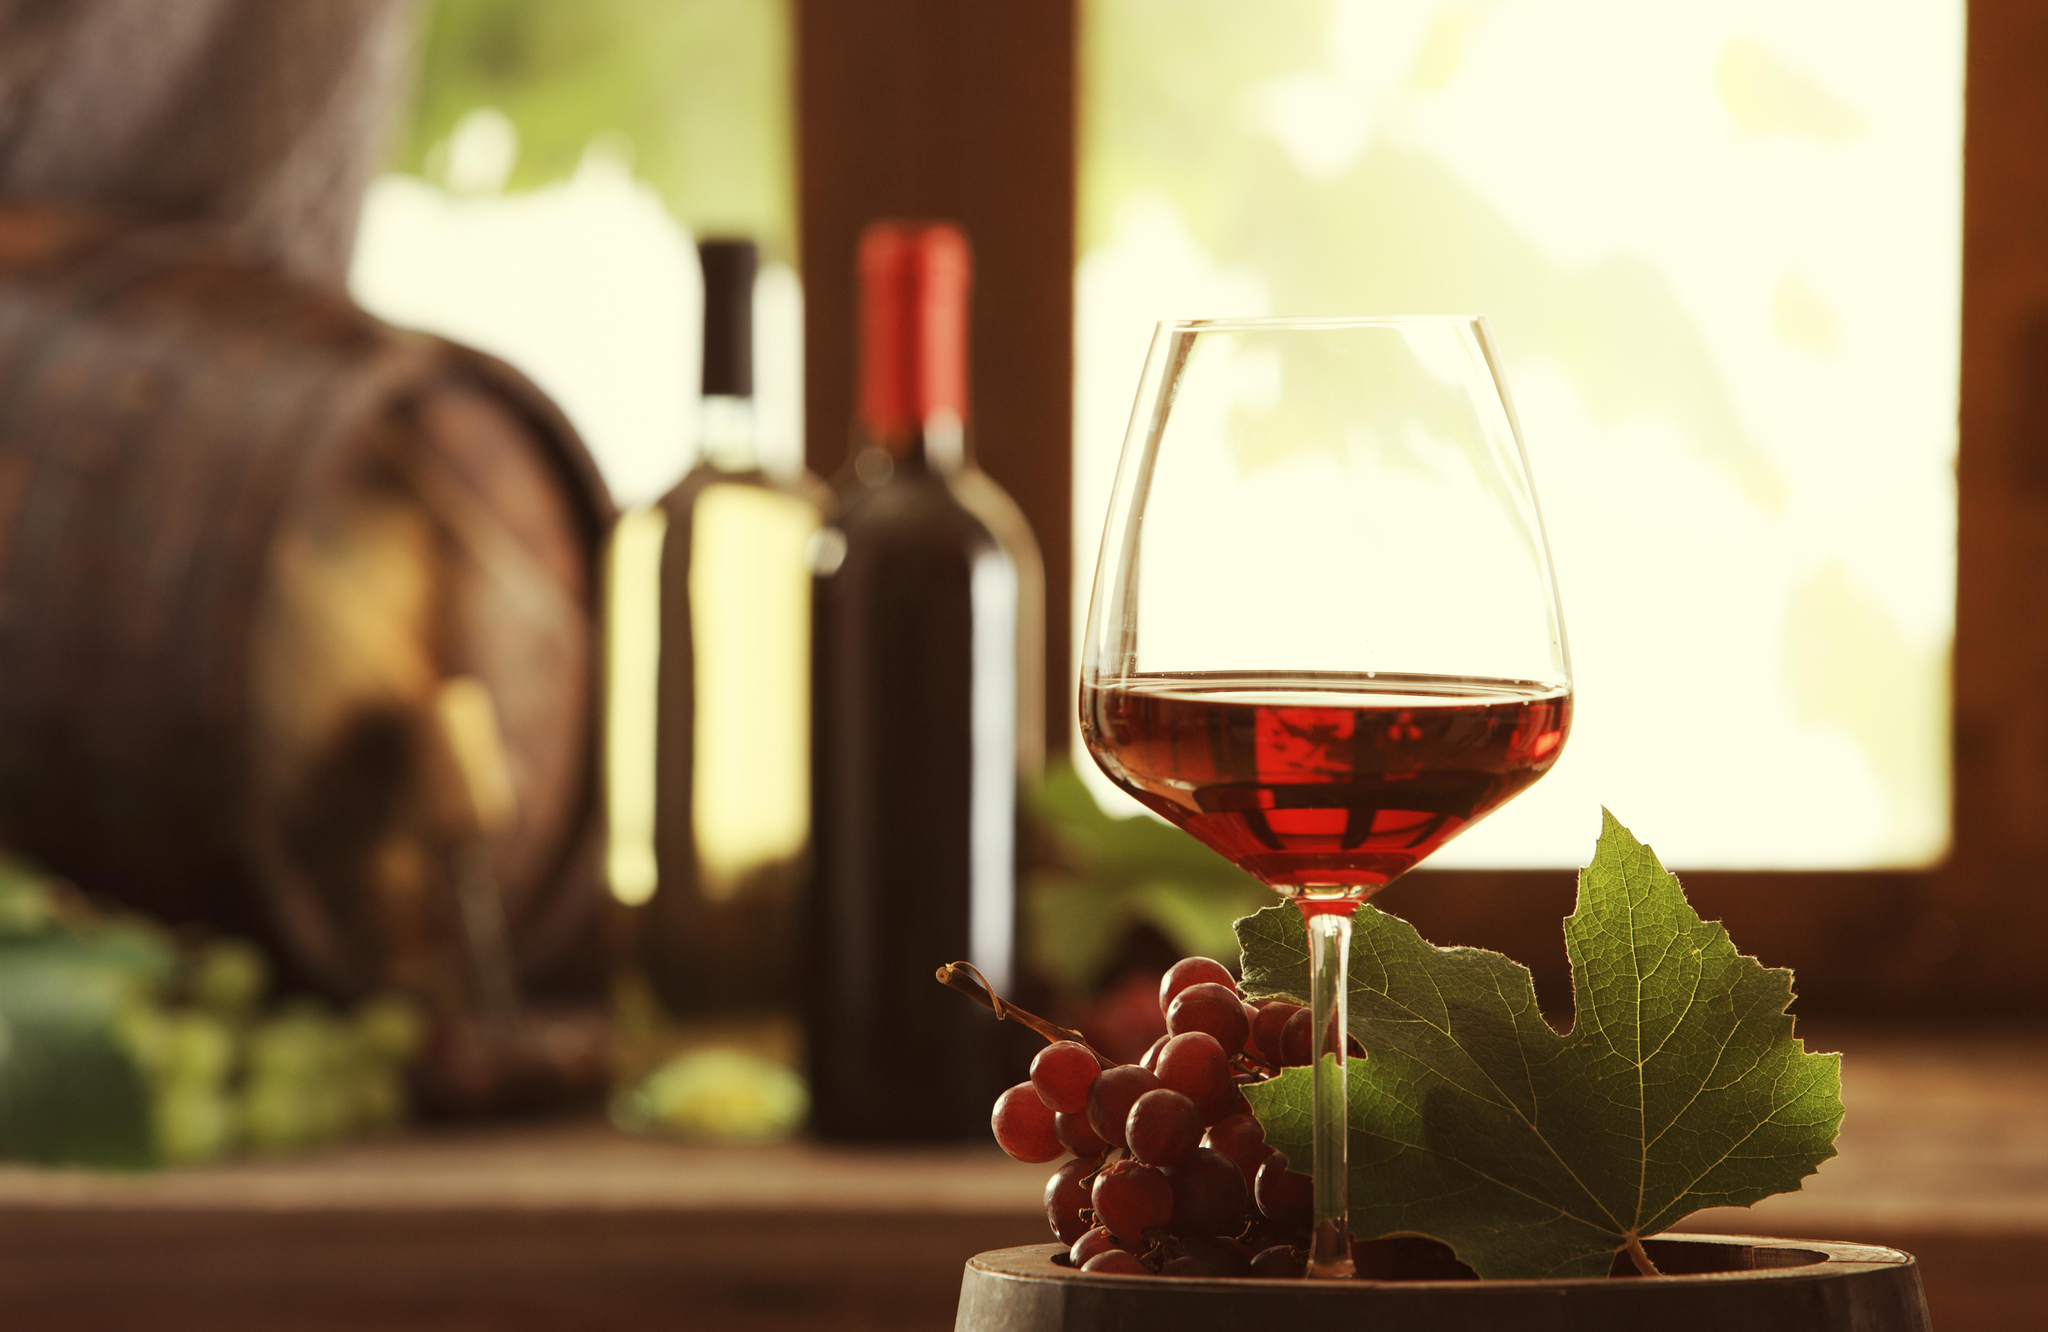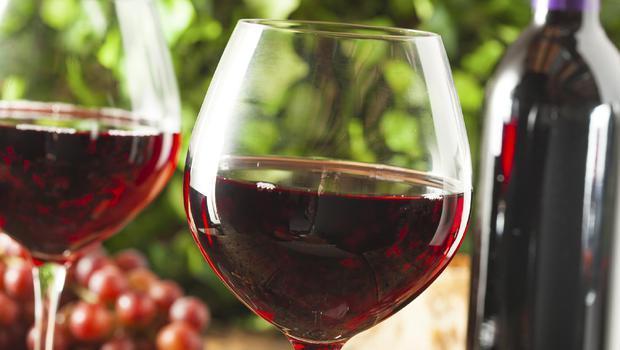The first image is the image on the left, the second image is the image on the right. Assess this claim about the two images: "At least one image shows a bunch of grapes near a glass partly filled with red wine.". Correct or not? Answer yes or no. Yes. The first image is the image on the left, the second image is the image on the right. Examine the images to the left and right. Is the description "In one of the images there are two wine glasses next to at least one bottle of wine and a bunch of grapes." accurate? Answer yes or no. Yes. 